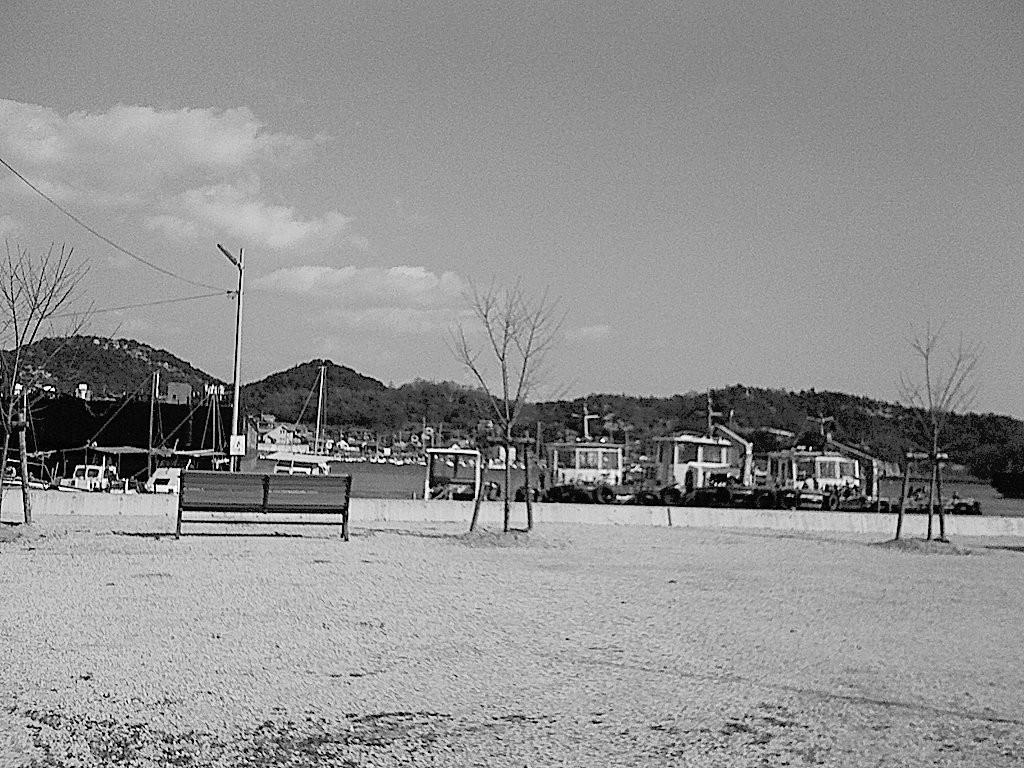What is the color scheme of the image? The image is black and white. What type of structure can be seen in the image? There is a bench in the image. What other objects are present in the image? There are poles and trees in the image. What type of natural feature is visible in the image? There is a mountain in the image. What can be seen in the background of the image? The sky with clouds is visible in the background. What type of cabbage is growing on the mountain in the image? There is no cabbage present in the image, and the mountain does not have any vegetation growing on it. What emotion is the bench feeling in the image? The bench is an inanimate object and does not have emotions like shame. 